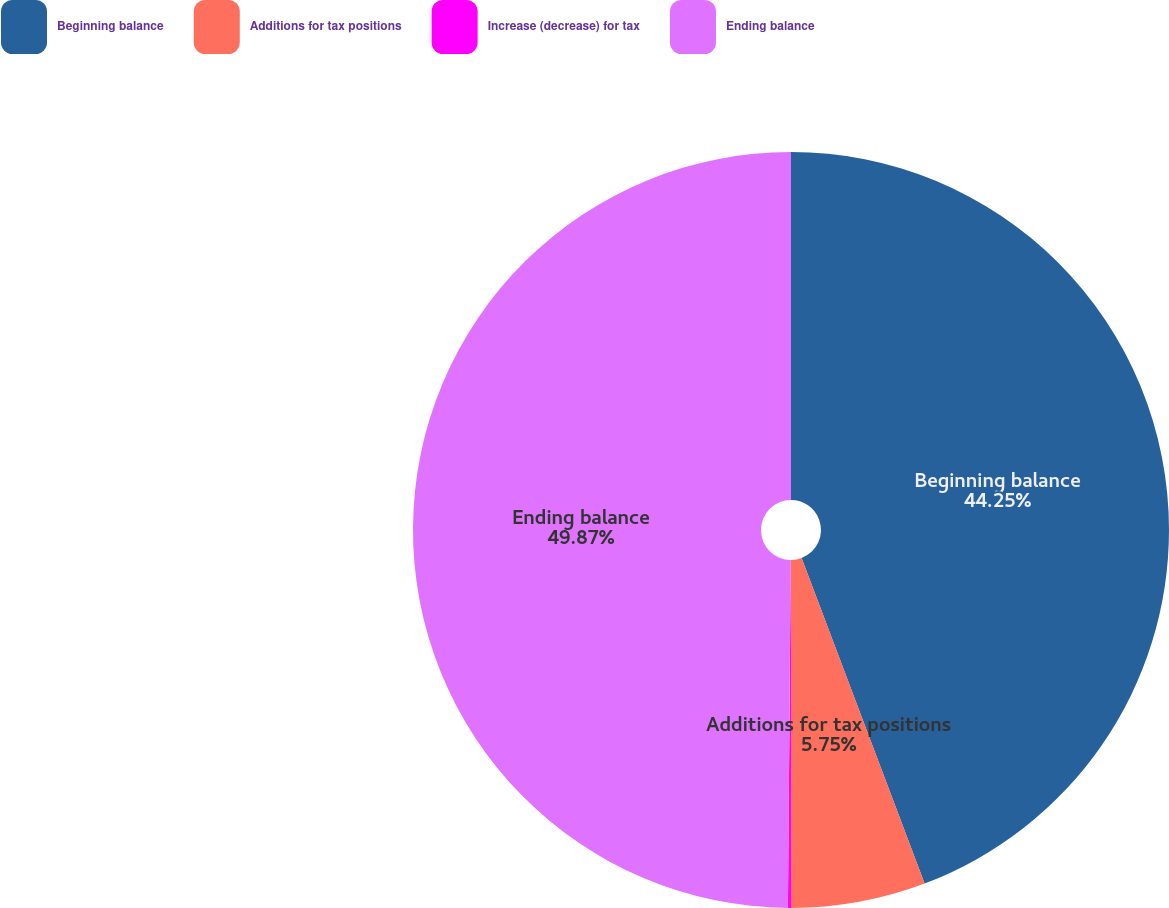Convert chart to OTSL. <chart><loc_0><loc_0><loc_500><loc_500><pie_chart><fcel>Beginning balance<fcel>Additions for tax positions<fcel>Increase (decrease) for tax<fcel>Ending balance<nl><fcel>44.25%<fcel>5.75%<fcel>0.13%<fcel>49.87%<nl></chart> 